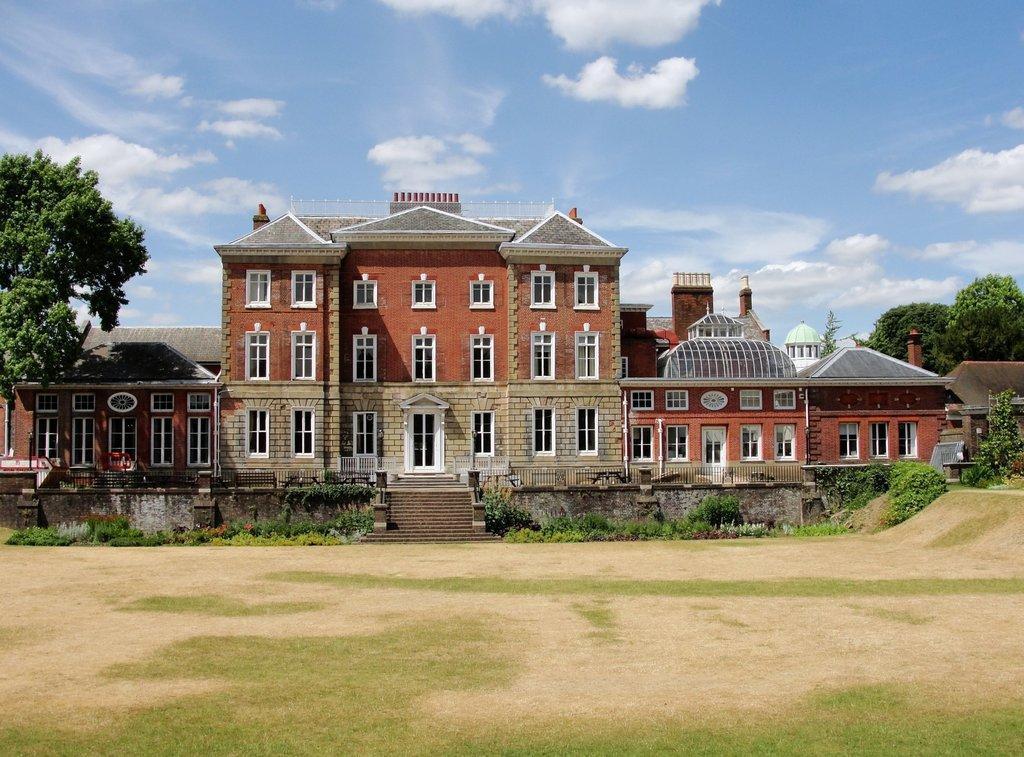Describe this image in one or two sentences. In this image I see a building which is of grey, white, orange and light brown in color and I see windows and doors and I see the ground on which there is grass, plants and I see the steps over here. In the background I see the trees and the clear sky. 